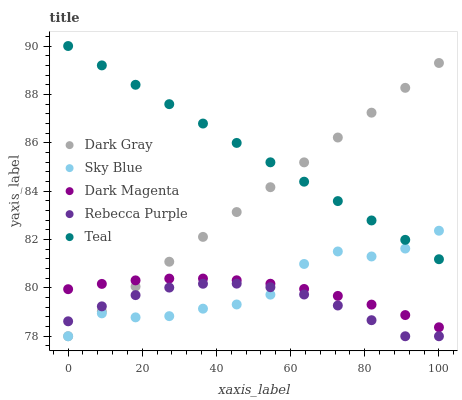Does Rebecca Purple have the minimum area under the curve?
Answer yes or no. Yes. Does Teal have the maximum area under the curve?
Answer yes or no. Yes. Does Sky Blue have the minimum area under the curve?
Answer yes or no. No. Does Sky Blue have the maximum area under the curve?
Answer yes or no. No. Is Teal the smoothest?
Answer yes or no. Yes. Is Sky Blue the roughest?
Answer yes or no. Yes. Is Dark Magenta the smoothest?
Answer yes or no. No. Is Dark Magenta the roughest?
Answer yes or no. No. Does Dark Gray have the lowest value?
Answer yes or no. Yes. Does Dark Magenta have the lowest value?
Answer yes or no. No. Does Teal have the highest value?
Answer yes or no. Yes. Does Sky Blue have the highest value?
Answer yes or no. No. Is Dark Magenta less than Teal?
Answer yes or no. Yes. Is Dark Magenta greater than Rebecca Purple?
Answer yes or no. Yes. Does Sky Blue intersect Rebecca Purple?
Answer yes or no. Yes. Is Sky Blue less than Rebecca Purple?
Answer yes or no. No. Is Sky Blue greater than Rebecca Purple?
Answer yes or no. No. Does Dark Magenta intersect Teal?
Answer yes or no. No. 